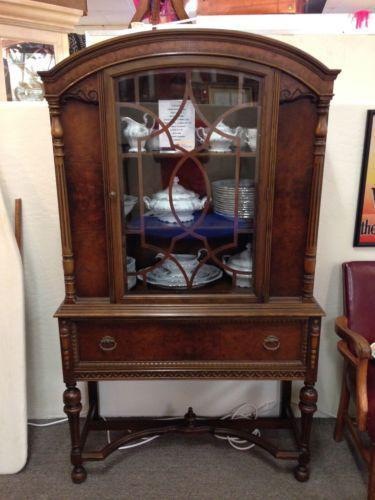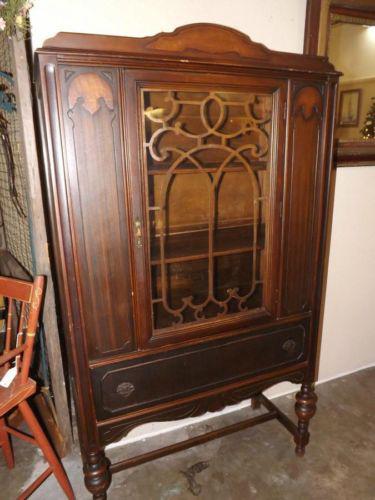The first image is the image on the left, the second image is the image on the right. Considering the images on both sides, is "There are dishes in one of the cabinets." valid? Answer yes or no. Yes. 